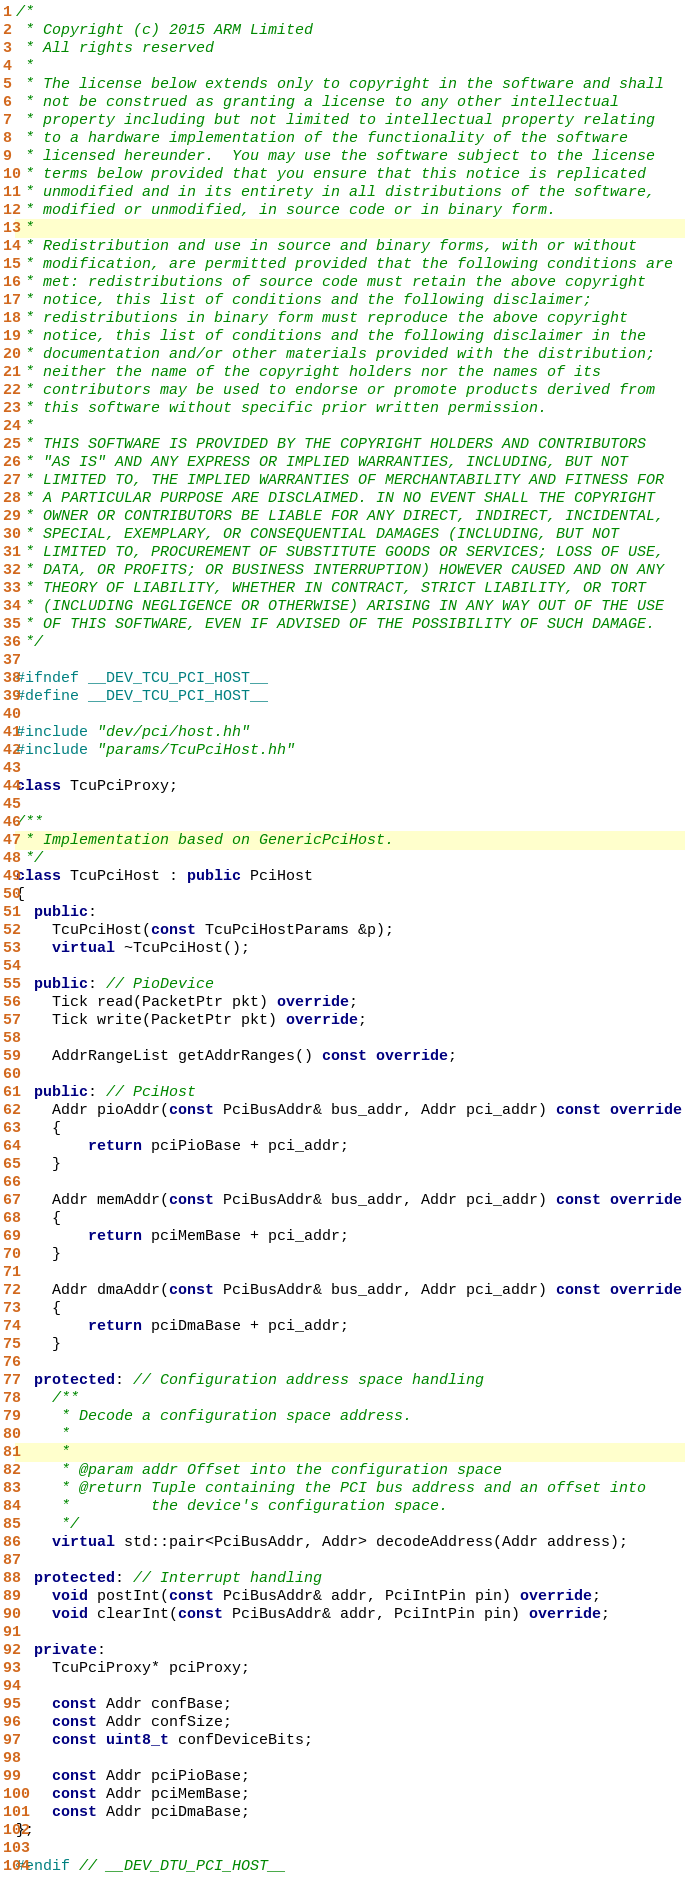Convert code to text. <code><loc_0><loc_0><loc_500><loc_500><_C++_>/*
 * Copyright (c) 2015 ARM Limited
 * All rights reserved
 *
 * The license below extends only to copyright in the software and shall
 * not be construed as granting a license to any other intellectual
 * property including but not limited to intellectual property relating
 * to a hardware implementation of the functionality of the software
 * licensed hereunder.  You may use the software subject to the license
 * terms below provided that you ensure that this notice is replicated
 * unmodified and in its entirety in all distributions of the software,
 * modified or unmodified, in source code or in binary form.
 *
 * Redistribution and use in source and binary forms, with or without
 * modification, are permitted provided that the following conditions are
 * met: redistributions of source code must retain the above copyright
 * notice, this list of conditions and the following disclaimer;
 * redistributions in binary form must reproduce the above copyright
 * notice, this list of conditions and the following disclaimer in the
 * documentation and/or other materials provided with the distribution;
 * neither the name of the copyright holders nor the names of its
 * contributors may be used to endorse or promote products derived from
 * this software without specific prior written permission.
 *
 * THIS SOFTWARE IS PROVIDED BY THE COPYRIGHT HOLDERS AND CONTRIBUTORS
 * "AS IS" AND ANY EXPRESS OR IMPLIED WARRANTIES, INCLUDING, BUT NOT
 * LIMITED TO, THE IMPLIED WARRANTIES OF MERCHANTABILITY AND FITNESS FOR
 * A PARTICULAR PURPOSE ARE DISCLAIMED. IN NO EVENT SHALL THE COPYRIGHT
 * OWNER OR CONTRIBUTORS BE LIABLE FOR ANY DIRECT, INDIRECT, INCIDENTAL,
 * SPECIAL, EXEMPLARY, OR CONSEQUENTIAL DAMAGES (INCLUDING, BUT NOT
 * LIMITED TO, PROCUREMENT OF SUBSTITUTE GOODS OR SERVICES; LOSS OF USE,
 * DATA, OR PROFITS; OR BUSINESS INTERRUPTION) HOWEVER CAUSED AND ON ANY
 * THEORY OF LIABILITY, WHETHER IN CONTRACT, STRICT LIABILITY, OR TORT
 * (INCLUDING NEGLIGENCE OR OTHERWISE) ARISING IN ANY WAY OUT OF THE USE
 * OF THIS SOFTWARE, EVEN IF ADVISED OF THE POSSIBILITY OF SUCH DAMAGE.
 */

#ifndef __DEV_TCU_PCI_HOST__
#define __DEV_TCU_PCI_HOST__

#include "dev/pci/host.hh"
#include "params/TcuPciHost.hh"

class TcuPciProxy;

/**
 * Implementation based on GenericPciHost.
 */
class TcuPciHost : public PciHost
{
  public:
    TcuPciHost(const TcuPciHostParams &p);
    virtual ~TcuPciHost();

  public: // PioDevice
    Tick read(PacketPtr pkt) override;
    Tick write(PacketPtr pkt) override;

    AddrRangeList getAddrRanges() const override;

  public: // PciHost
    Addr pioAddr(const PciBusAddr& bus_addr, Addr pci_addr) const override
    {
        return pciPioBase + pci_addr;
    }

    Addr memAddr(const PciBusAddr& bus_addr, Addr pci_addr) const override
    {
        return pciMemBase + pci_addr;
    }

    Addr dmaAddr(const PciBusAddr& bus_addr, Addr pci_addr) const override
    {
        return pciDmaBase + pci_addr;
    }

  protected: // Configuration address space handling
    /**
     * Decode a configuration space address.
     *
     *
     * @param addr Offset into the configuration space
     * @return Tuple containing the PCI bus address and an offset into
     *         the device's configuration space.
     */
    virtual std::pair<PciBusAddr, Addr> decodeAddress(Addr address);

  protected: // Interrupt handling
    void postInt(const PciBusAddr& addr, PciIntPin pin) override;
    void clearInt(const PciBusAddr& addr, PciIntPin pin) override;

  private:
    TcuPciProxy* pciProxy;

    const Addr confBase;
    const Addr confSize;
    const uint8_t confDeviceBits;

    const Addr pciPioBase;
    const Addr pciMemBase;
    const Addr pciDmaBase;
};

#endif // __DEV_DTU_PCI_HOST__
</code> 